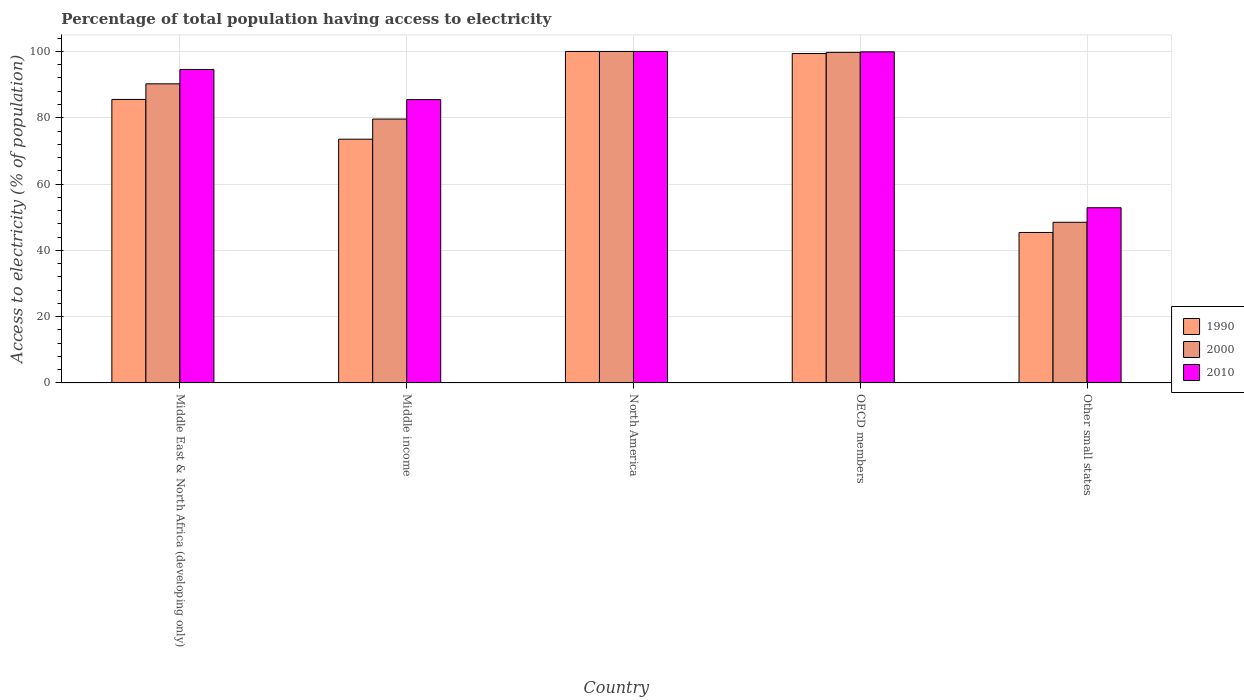How many different coloured bars are there?
Your answer should be compact. 3. How many bars are there on the 5th tick from the left?
Your response must be concise. 3. How many bars are there on the 2nd tick from the right?
Your answer should be very brief. 3. What is the label of the 5th group of bars from the left?
Offer a very short reply. Other small states. In how many cases, is the number of bars for a given country not equal to the number of legend labels?
Provide a short and direct response. 0. What is the percentage of population that have access to electricity in 2010 in OECD members?
Your answer should be very brief. 99.88. Across all countries, what is the minimum percentage of population that have access to electricity in 2000?
Your response must be concise. 48.47. In which country was the percentage of population that have access to electricity in 2000 maximum?
Offer a terse response. North America. In which country was the percentage of population that have access to electricity in 2000 minimum?
Provide a succinct answer. Other small states. What is the total percentage of population that have access to electricity in 1990 in the graph?
Provide a short and direct response. 403.82. What is the difference between the percentage of population that have access to electricity in 1990 in Middle income and that in North America?
Give a very brief answer. -26.47. What is the difference between the percentage of population that have access to electricity in 2000 in OECD members and the percentage of population that have access to electricity in 1990 in Other small states?
Provide a short and direct response. 54.34. What is the average percentage of population that have access to electricity in 1990 per country?
Ensure brevity in your answer.  80.76. What is the difference between the percentage of population that have access to electricity of/in 1990 and percentage of population that have access to electricity of/in 2010 in North America?
Your answer should be very brief. 0. What is the ratio of the percentage of population that have access to electricity in 2010 in Middle income to that in Other small states?
Give a very brief answer. 1.62. Is the percentage of population that have access to electricity in 1990 in OECD members less than that in Other small states?
Give a very brief answer. No. Is the difference between the percentage of population that have access to electricity in 1990 in Middle East & North Africa (developing only) and North America greater than the difference between the percentage of population that have access to electricity in 2010 in Middle East & North Africa (developing only) and North America?
Your response must be concise. No. What is the difference between the highest and the second highest percentage of population that have access to electricity in 2000?
Make the answer very short. -9.49. What is the difference between the highest and the lowest percentage of population that have access to electricity in 1990?
Your answer should be compact. 54.61. In how many countries, is the percentage of population that have access to electricity in 2000 greater than the average percentage of population that have access to electricity in 2000 taken over all countries?
Provide a short and direct response. 3. How many bars are there?
Your answer should be compact. 15. Are all the bars in the graph horizontal?
Make the answer very short. No. How many countries are there in the graph?
Provide a succinct answer. 5. How many legend labels are there?
Provide a succinct answer. 3. What is the title of the graph?
Your answer should be very brief. Percentage of total population having access to electricity. What is the label or title of the X-axis?
Make the answer very short. Country. What is the label or title of the Y-axis?
Keep it short and to the point. Access to electricity (% of population). What is the Access to electricity (% of population) in 1990 in Middle East & North Africa (developing only)?
Give a very brief answer. 85.53. What is the Access to electricity (% of population) of 2000 in Middle East & North Africa (developing only)?
Provide a succinct answer. 90.23. What is the Access to electricity (% of population) of 2010 in Middle East & North Africa (developing only)?
Provide a short and direct response. 94.57. What is the Access to electricity (% of population) in 1990 in Middle income?
Your answer should be compact. 73.53. What is the Access to electricity (% of population) of 2000 in Middle income?
Provide a short and direct response. 79.61. What is the Access to electricity (% of population) in 2010 in Middle income?
Make the answer very short. 85.47. What is the Access to electricity (% of population) in 1990 in North America?
Your answer should be compact. 100. What is the Access to electricity (% of population) of 2000 in North America?
Offer a terse response. 100. What is the Access to electricity (% of population) of 2010 in North America?
Offer a very short reply. 100. What is the Access to electricity (% of population) in 1990 in OECD members?
Your response must be concise. 99.37. What is the Access to electricity (% of population) in 2000 in OECD members?
Make the answer very short. 99.72. What is the Access to electricity (% of population) in 2010 in OECD members?
Give a very brief answer. 99.88. What is the Access to electricity (% of population) in 1990 in Other small states?
Provide a succinct answer. 45.39. What is the Access to electricity (% of population) of 2000 in Other small states?
Give a very brief answer. 48.47. What is the Access to electricity (% of population) of 2010 in Other small states?
Provide a succinct answer. 52.85. Across all countries, what is the maximum Access to electricity (% of population) in 2000?
Give a very brief answer. 100. Across all countries, what is the maximum Access to electricity (% of population) in 2010?
Ensure brevity in your answer.  100. Across all countries, what is the minimum Access to electricity (% of population) of 1990?
Your response must be concise. 45.39. Across all countries, what is the minimum Access to electricity (% of population) in 2000?
Offer a very short reply. 48.47. Across all countries, what is the minimum Access to electricity (% of population) of 2010?
Keep it short and to the point. 52.85. What is the total Access to electricity (% of population) in 1990 in the graph?
Your answer should be very brief. 403.82. What is the total Access to electricity (% of population) of 2000 in the graph?
Ensure brevity in your answer.  418.03. What is the total Access to electricity (% of population) of 2010 in the graph?
Offer a very short reply. 432.77. What is the difference between the Access to electricity (% of population) in 1990 in Middle East & North Africa (developing only) and that in Middle income?
Offer a terse response. 12. What is the difference between the Access to electricity (% of population) in 2000 in Middle East & North Africa (developing only) and that in Middle income?
Your answer should be very brief. 10.62. What is the difference between the Access to electricity (% of population) in 2010 in Middle East & North Africa (developing only) and that in Middle income?
Your answer should be very brief. 9.09. What is the difference between the Access to electricity (% of population) of 1990 in Middle East & North Africa (developing only) and that in North America?
Offer a very short reply. -14.47. What is the difference between the Access to electricity (% of population) in 2000 in Middle East & North Africa (developing only) and that in North America?
Provide a succinct answer. -9.77. What is the difference between the Access to electricity (% of population) of 2010 in Middle East & North Africa (developing only) and that in North America?
Your answer should be very brief. -5.43. What is the difference between the Access to electricity (% of population) in 1990 in Middle East & North Africa (developing only) and that in OECD members?
Offer a terse response. -13.84. What is the difference between the Access to electricity (% of population) of 2000 in Middle East & North Africa (developing only) and that in OECD members?
Make the answer very short. -9.49. What is the difference between the Access to electricity (% of population) in 2010 in Middle East & North Africa (developing only) and that in OECD members?
Your response must be concise. -5.31. What is the difference between the Access to electricity (% of population) in 1990 in Middle East & North Africa (developing only) and that in Other small states?
Your answer should be compact. 40.14. What is the difference between the Access to electricity (% of population) in 2000 in Middle East & North Africa (developing only) and that in Other small states?
Offer a terse response. 41.76. What is the difference between the Access to electricity (% of population) in 2010 in Middle East & North Africa (developing only) and that in Other small states?
Your response must be concise. 41.72. What is the difference between the Access to electricity (% of population) of 1990 in Middle income and that in North America?
Offer a terse response. -26.47. What is the difference between the Access to electricity (% of population) in 2000 in Middle income and that in North America?
Offer a very short reply. -20.39. What is the difference between the Access to electricity (% of population) in 2010 in Middle income and that in North America?
Provide a succinct answer. -14.53. What is the difference between the Access to electricity (% of population) in 1990 in Middle income and that in OECD members?
Offer a terse response. -25.84. What is the difference between the Access to electricity (% of population) of 2000 in Middle income and that in OECD members?
Ensure brevity in your answer.  -20.12. What is the difference between the Access to electricity (% of population) in 2010 in Middle income and that in OECD members?
Offer a very short reply. -14.41. What is the difference between the Access to electricity (% of population) of 1990 in Middle income and that in Other small states?
Offer a very short reply. 28.14. What is the difference between the Access to electricity (% of population) of 2000 in Middle income and that in Other small states?
Ensure brevity in your answer.  31.14. What is the difference between the Access to electricity (% of population) of 2010 in Middle income and that in Other small states?
Ensure brevity in your answer.  32.62. What is the difference between the Access to electricity (% of population) in 1990 in North America and that in OECD members?
Offer a terse response. 0.63. What is the difference between the Access to electricity (% of population) in 2000 in North America and that in OECD members?
Offer a terse response. 0.28. What is the difference between the Access to electricity (% of population) of 2010 in North America and that in OECD members?
Provide a short and direct response. 0.12. What is the difference between the Access to electricity (% of population) of 1990 in North America and that in Other small states?
Provide a short and direct response. 54.61. What is the difference between the Access to electricity (% of population) in 2000 in North America and that in Other small states?
Keep it short and to the point. 51.53. What is the difference between the Access to electricity (% of population) in 2010 in North America and that in Other small states?
Your response must be concise. 47.15. What is the difference between the Access to electricity (% of population) in 1990 in OECD members and that in Other small states?
Give a very brief answer. 53.98. What is the difference between the Access to electricity (% of population) in 2000 in OECD members and that in Other small states?
Offer a very short reply. 51.25. What is the difference between the Access to electricity (% of population) in 2010 in OECD members and that in Other small states?
Keep it short and to the point. 47.03. What is the difference between the Access to electricity (% of population) in 1990 in Middle East & North Africa (developing only) and the Access to electricity (% of population) in 2000 in Middle income?
Your answer should be very brief. 5.92. What is the difference between the Access to electricity (% of population) in 1990 in Middle East & North Africa (developing only) and the Access to electricity (% of population) in 2010 in Middle income?
Offer a terse response. 0.05. What is the difference between the Access to electricity (% of population) in 2000 in Middle East & North Africa (developing only) and the Access to electricity (% of population) in 2010 in Middle income?
Make the answer very short. 4.76. What is the difference between the Access to electricity (% of population) of 1990 in Middle East & North Africa (developing only) and the Access to electricity (% of population) of 2000 in North America?
Provide a succinct answer. -14.47. What is the difference between the Access to electricity (% of population) of 1990 in Middle East & North Africa (developing only) and the Access to electricity (% of population) of 2010 in North America?
Make the answer very short. -14.47. What is the difference between the Access to electricity (% of population) in 2000 in Middle East & North Africa (developing only) and the Access to electricity (% of population) in 2010 in North America?
Provide a succinct answer. -9.77. What is the difference between the Access to electricity (% of population) of 1990 in Middle East & North Africa (developing only) and the Access to electricity (% of population) of 2000 in OECD members?
Ensure brevity in your answer.  -14.2. What is the difference between the Access to electricity (% of population) in 1990 in Middle East & North Africa (developing only) and the Access to electricity (% of population) in 2010 in OECD members?
Provide a succinct answer. -14.35. What is the difference between the Access to electricity (% of population) of 2000 in Middle East & North Africa (developing only) and the Access to electricity (% of population) of 2010 in OECD members?
Keep it short and to the point. -9.65. What is the difference between the Access to electricity (% of population) in 1990 in Middle East & North Africa (developing only) and the Access to electricity (% of population) in 2000 in Other small states?
Your answer should be very brief. 37.06. What is the difference between the Access to electricity (% of population) in 1990 in Middle East & North Africa (developing only) and the Access to electricity (% of population) in 2010 in Other small states?
Your answer should be very brief. 32.68. What is the difference between the Access to electricity (% of population) of 2000 in Middle East & North Africa (developing only) and the Access to electricity (% of population) of 2010 in Other small states?
Your answer should be very brief. 37.38. What is the difference between the Access to electricity (% of population) in 1990 in Middle income and the Access to electricity (% of population) in 2000 in North America?
Ensure brevity in your answer.  -26.47. What is the difference between the Access to electricity (% of population) of 1990 in Middle income and the Access to electricity (% of population) of 2010 in North America?
Keep it short and to the point. -26.47. What is the difference between the Access to electricity (% of population) in 2000 in Middle income and the Access to electricity (% of population) in 2010 in North America?
Your response must be concise. -20.39. What is the difference between the Access to electricity (% of population) in 1990 in Middle income and the Access to electricity (% of population) in 2000 in OECD members?
Your answer should be very brief. -26.19. What is the difference between the Access to electricity (% of population) in 1990 in Middle income and the Access to electricity (% of population) in 2010 in OECD members?
Offer a very short reply. -26.35. What is the difference between the Access to electricity (% of population) in 2000 in Middle income and the Access to electricity (% of population) in 2010 in OECD members?
Your response must be concise. -20.27. What is the difference between the Access to electricity (% of population) in 1990 in Middle income and the Access to electricity (% of population) in 2000 in Other small states?
Your response must be concise. 25.06. What is the difference between the Access to electricity (% of population) in 1990 in Middle income and the Access to electricity (% of population) in 2010 in Other small states?
Your response must be concise. 20.68. What is the difference between the Access to electricity (% of population) of 2000 in Middle income and the Access to electricity (% of population) of 2010 in Other small states?
Provide a short and direct response. 26.76. What is the difference between the Access to electricity (% of population) in 1990 in North America and the Access to electricity (% of population) in 2000 in OECD members?
Your answer should be compact. 0.28. What is the difference between the Access to electricity (% of population) in 1990 in North America and the Access to electricity (% of population) in 2010 in OECD members?
Ensure brevity in your answer.  0.12. What is the difference between the Access to electricity (% of population) of 2000 in North America and the Access to electricity (% of population) of 2010 in OECD members?
Provide a short and direct response. 0.12. What is the difference between the Access to electricity (% of population) in 1990 in North America and the Access to electricity (% of population) in 2000 in Other small states?
Your response must be concise. 51.53. What is the difference between the Access to electricity (% of population) of 1990 in North America and the Access to electricity (% of population) of 2010 in Other small states?
Your response must be concise. 47.15. What is the difference between the Access to electricity (% of population) of 2000 in North America and the Access to electricity (% of population) of 2010 in Other small states?
Your response must be concise. 47.15. What is the difference between the Access to electricity (% of population) of 1990 in OECD members and the Access to electricity (% of population) of 2000 in Other small states?
Keep it short and to the point. 50.9. What is the difference between the Access to electricity (% of population) in 1990 in OECD members and the Access to electricity (% of population) in 2010 in Other small states?
Make the answer very short. 46.52. What is the difference between the Access to electricity (% of population) in 2000 in OECD members and the Access to electricity (% of population) in 2010 in Other small states?
Provide a short and direct response. 46.88. What is the average Access to electricity (% of population) of 1990 per country?
Your response must be concise. 80.76. What is the average Access to electricity (% of population) of 2000 per country?
Your response must be concise. 83.61. What is the average Access to electricity (% of population) in 2010 per country?
Make the answer very short. 86.55. What is the difference between the Access to electricity (% of population) of 1990 and Access to electricity (% of population) of 2000 in Middle East & North Africa (developing only)?
Your response must be concise. -4.7. What is the difference between the Access to electricity (% of population) in 1990 and Access to electricity (% of population) in 2010 in Middle East & North Africa (developing only)?
Give a very brief answer. -9.04. What is the difference between the Access to electricity (% of population) in 2000 and Access to electricity (% of population) in 2010 in Middle East & North Africa (developing only)?
Provide a succinct answer. -4.34. What is the difference between the Access to electricity (% of population) of 1990 and Access to electricity (% of population) of 2000 in Middle income?
Make the answer very short. -6.08. What is the difference between the Access to electricity (% of population) of 1990 and Access to electricity (% of population) of 2010 in Middle income?
Provide a succinct answer. -11.94. What is the difference between the Access to electricity (% of population) of 2000 and Access to electricity (% of population) of 2010 in Middle income?
Provide a succinct answer. -5.87. What is the difference between the Access to electricity (% of population) in 1990 and Access to electricity (% of population) in 2000 in North America?
Provide a succinct answer. 0. What is the difference between the Access to electricity (% of population) in 1990 and Access to electricity (% of population) in 2010 in North America?
Provide a short and direct response. 0. What is the difference between the Access to electricity (% of population) in 1990 and Access to electricity (% of population) in 2000 in OECD members?
Provide a short and direct response. -0.35. What is the difference between the Access to electricity (% of population) of 1990 and Access to electricity (% of population) of 2010 in OECD members?
Make the answer very short. -0.51. What is the difference between the Access to electricity (% of population) of 2000 and Access to electricity (% of population) of 2010 in OECD members?
Your response must be concise. -0.15. What is the difference between the Access to electricity (% of population) in 1990 and Access to electricity (% of population) in 2000 in Other small states?
Your answer should be very brief. -3.08. What is the difference between the Access to electricity (% of population) in 1990 and Access to electricity (% of population) in 2010 in Other small states?
Provide a succinct answer. -7.46. What is the difference between the Access to electricity (% of population) of 2000 and Access to electricity (% of population) of 2010 in Other small states?
Your response must be concise. -4.38. What is the ratio of the Access to electricity (% of population) in 1990 in Middle East & North Africa (developing only) to that in Middle income?
Offer a terse response. 1.16. What is the ratio of the Access to electricity (% of population) of 2000 in Middle East & North Africa (developing only) to that in Middle income?
Provide a succinct answer. 1.13. What is the ratio of the Access to electricity (% of population) in 2010 in Middle East & North Africa (developing only) to that in Middle income?
Offer a terse response. 1.11. What is the ratio of the Access to electricity (% of population) in 1990 in Middle East & North Africa (developing only) to that in North America?
Your answer should be very brief. 0.86. What is the ratio of the Access to electricity (% of population) of 2000 in Middle East & North Africa (developing only) to that in North America?
Offer a terse response. 0.9. What is the ratio of the Access to electricity (% of population) of 2010 in Middle East & North Africa (developing only) to that in North America?
Give a very brief answer. 0.95. What is the ratio of the Access to electricity (% of population) in 1990 in Middle East & North Africa (developing only) to that in OECD members?
Offer a very short reply. 0.86. What is the ratio of the Access to electricity (% of population) in 2000 in Middle East & North Africa (developing only) to that in OECD members?
Give a very brief answer. 0.9. What is the ratio of the Access to electricity (% of population) of 2010 in Middle East & North Africa (developing only) to that in OECD members?
Keep it short and to the point. 0.95. What is the ratio of the Access to electricity (% of population) of 1990 in Middle East & North Africa (developing only) to that in Other small states?
Provide a succinct answer. 1.88. What is the ratio of the Access to electricity (% of population) in 2000 in Middle East & North Africa (developing only) to that in Other small states?
Provide a short and direct response. 1.86. What is the ratio of the Access to electricity (% of population) in 2010 in Middle East & North Africa (developing only) to that in Other small states?
Your response must be concise. 1.79. What is the ratio of the Access to electricity (% of population) in 1990 in Middle income to that in North America?
Offer a very short reply. 0.74. What is the ratio of the Access to electricity (% of population) in 2000 in Middle income to that in North America?
Offer a terse response. 0.8. What is the ratio of the Access to electricity (% of population) of 2010 in Middle income to that in North America?
Offer a terse response. 0.85. What is the ratio of the Access to electricity (% of population) of 1990 in Middle income to that in OECD members?
Your answer should be compact. 0.74. What is the ratio of the Access to electricity (% of population) in 2000 in Middle income to that in OECD members?
Keep it short and to the point. 0.8. What is the ratio of the Access to electricity (% of population) in 2010 in Middle income to that in OECD members?
Make the answer very short. 0.86. What is the ratio of the Access to electricity (% of population) in 1990 in Middle income to that in Other small states?
Make the answer very short. 1.62. What is the ratio of the Access to electricity (% of population) of 2000 in Middle income to that in Other small states?
Provide a short and direct response. 1.64. What is the ratio of the Access to electricity (% of population) of 2010 in Middle income to that in Other small states?
Give a very brief answer. 1.62. What is the ratio of the Access to electricity (% of population) in 1990 in North America to that in OECD members?
Give a very brief answer. 1.01. What is the ratio of the Access to electricity (% of population) of 2010 in North America to that in OECD members?
Your answer should be compact. 1. What is the ratio of the Access to electricity (% of population) of 1990 in North America to that in Other small states?
Ensure brevity in your answer.  2.2. What is the ratio of the Access to electricity (% of population) in 2000 in North America to that in Other small states?
Give a very brief answer. 2.06. What is the ratio of the Access to electricity (% of population) of 2010 in North America to that in Other small states?
Offer a terse response. 1.89. What is the ratio of the Access to electricity (% of population) of 1990 in OECD members to that in Other small states?
Your answer should be very brief. 2.19. What is the ratio of the Access to electricity (% of population) of 2000 in OECD members to that in Other small states?
Your answer should be compact. 2.06. What is the ratio of the Access to electricity (% of population) in 2010 in OECD members to that in Other small states?
Provide a short and direct response. 1.89. What is the difference between the highest and the second highest Access to electricity (% of population) of 1990?
Keep it short and to the point. 0.63. What is the difference between the highest and the second highest Access to electricity (% of population) in 2000?
Your answer should be very brief. 0.28. What is the difference between the highest and the second highest Access to electricity (% of population) of 2010?
Your answer should be very brief. 0.12. What is the difference between the highest and the lowest Access to electricity (% of population) of 1990?
Your answer should be very brief. 54.61. What is the difference between the highest and the lowest Access to electricity (% of population) in 2000?
Offer a very short reply. 51.53. What is the difference between the highest and the lowest Access to electricity (% of population) of 2010?
Offer a very short reply. 47.15. 